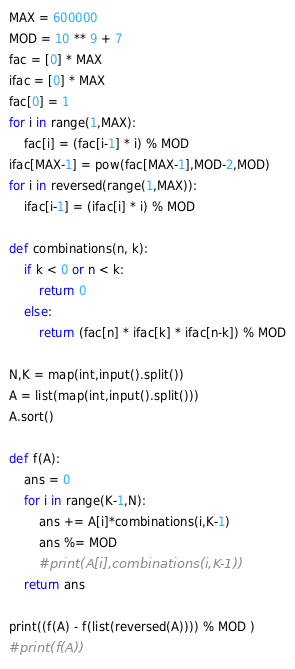<code> <loc_0><loc_0><loc_500><loc_500><_Python_>MAX = 600000
MOD = 10 ** 9 + 7
fac = [0] * MAX
ifac = [0] * MAX
fac[0] = 1
for i in range(1,MAX):
    fac[i] = (fac[i-1] * i) % MOD
ifac[MAX-1] = pow(fac[MAX-1],MOD-2,MOD)
for i in reversed(range(1,MAX)):
    ifac[i-1] = (ifac[i] * i) % MOD

def combinations(n, k):
    if k < 0 or n < k:
        return 0
    else:
        return (fac[n] * ifac[k] * ifac[n-k]) % MOD

N,K = map(int,input().split())
A = list(map(int,input().split()))
A.sort()

def f(A):
    ans = 0
    for i in range(K-1,N):
        ans += A[i]*combinations(i,K-1)
        ans %= MOD
        #print(A[i],combinations(i,K-1))
    return ans

print((f(A) - f(list(reversed(A)))) % MOD )
#print(f(A))

</code> 